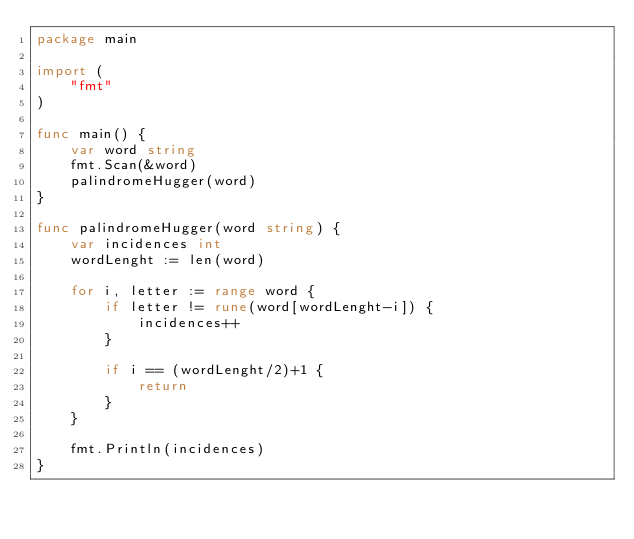<code> <loc_0><loc_0><loc_500><loc_500><_Go_>package main

import (
	"fmt"
)

func main() {
	var word string
	fmt.Scan(&word)
	palindromeHugger(word)
}

func palindromeHugger(word string) {
	var incidences int
	wordLenght := len(word)

	for i, letter := range word {
		if letter != rune(word[wordLenght-i]) {
			incidences++
		}

		if i == (wordLenght/2)+1 {
			return
		}
	}

	fmt.Println(incidences)
}
</code> 